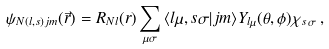<formula> <loc_0><loc_0><loc_500><loc_500>\psi _ { N ( l , s ) j m } ( \vec { r } ) = R _ { N l } ( r ) \sum _ { \mu \sigma } { \langle l \mu , s \sigma | j m \rangle } Y _ { l \mu } ( \theta , \phi ) \chi _ { s \, \sigma } \, ,</formula> 